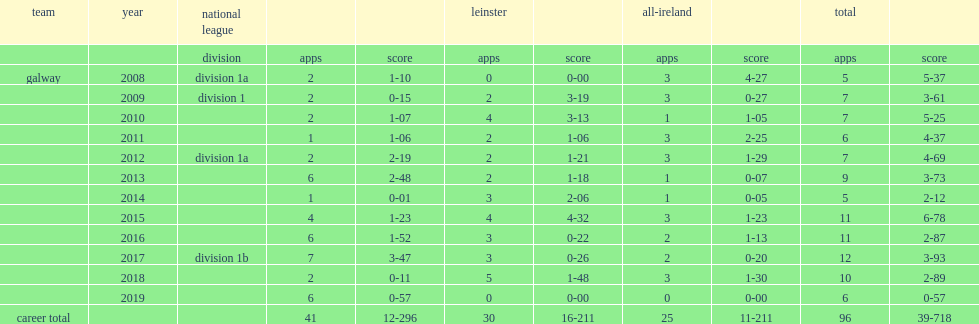Which team did canning play for in 2016? Galway. 